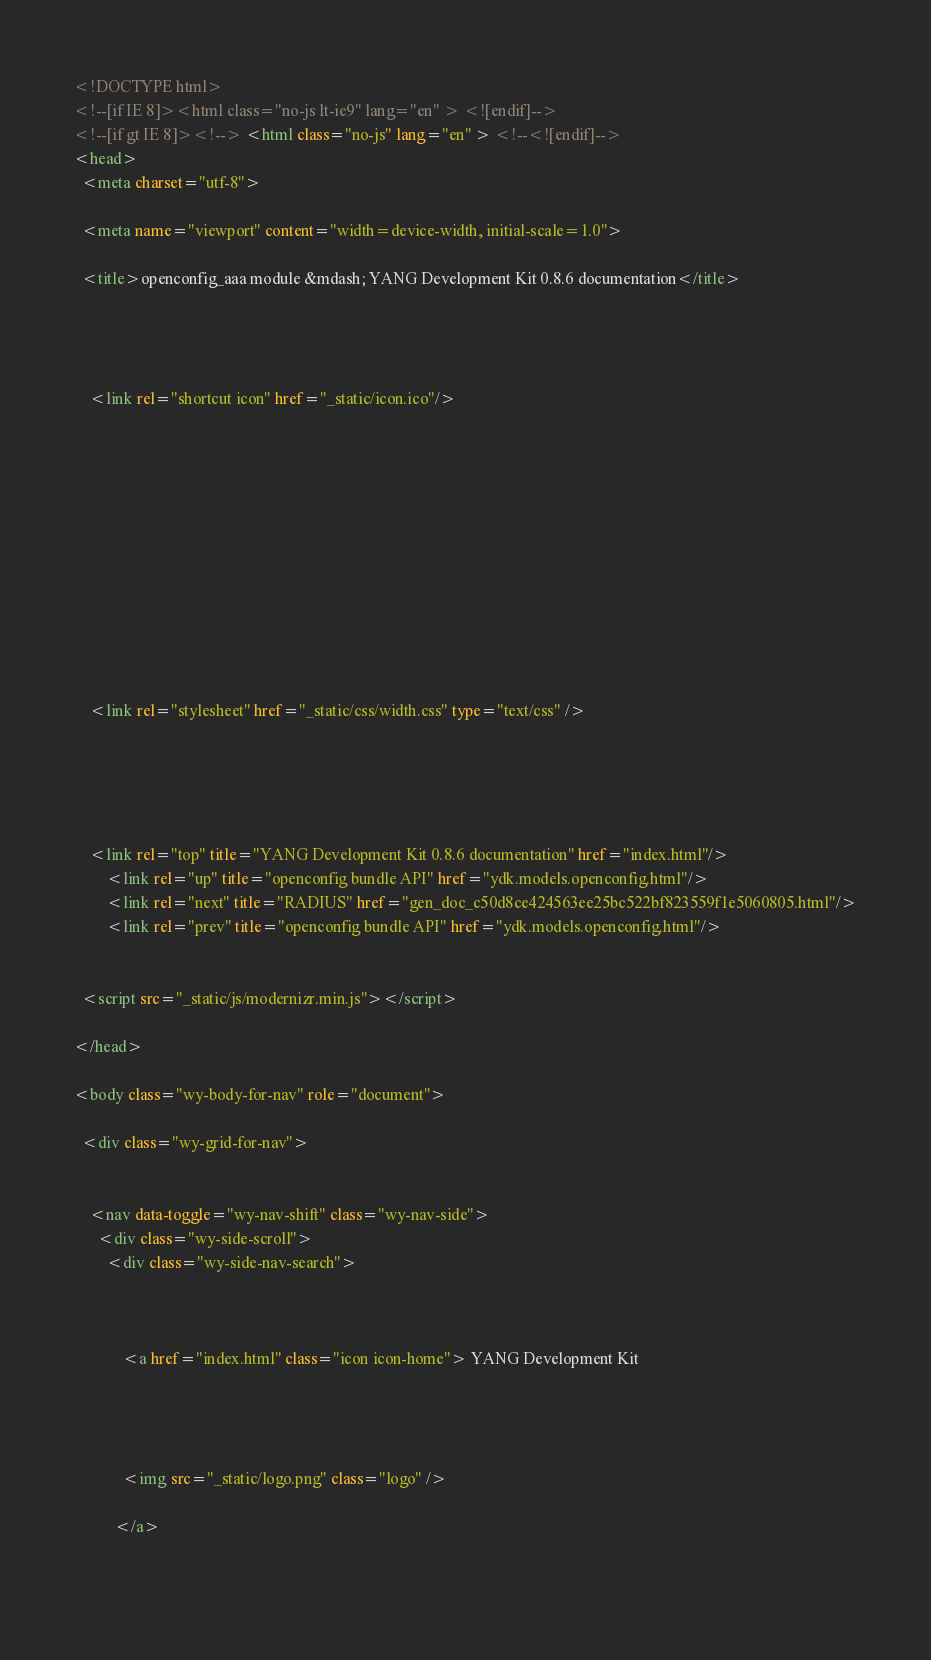Convert code to text. <code><loc_0><loc_0><loc_500><loc_500><_HTML_>

<!DOCTYPE html>
<!--[if IE 8]><html class="no-js lt-ie9" lang="en" > <![endif]-->
<!--[if gt IE 8]><!--> <html class="no-js" lang="en" > <!--<![endif]-->
<head>
  <meta charset="utf-8">
  
  <meta name="viewport" content="width=device-width, initial-scale=1.0">
  
  <title>openconfig_aaa module &mdash; YANG Development Kit 0.8.6 documentation</title>
  

  
  
    <link rel="shortcut icon" href="_static/icon.ico"/>
  

  

  
  
    

  

  
  
    <link rel="stylesheet" href="_static/css/width.css" type="text/css" />
  

  

  
    <link rel="top" title="YANG Development Kit 0.8.6 documentation" href="index.html"/>
        <link rel="up" title="openconfig bundle API" href="ydk.models.openconfig.html"/>
        <link rel="next" title="RADIUS" href="gen_doc_c50d8ce424563ee25bc522bf823559f1e5060805.html"/>
        <link rel="prev" title="openconfig bundle API" href="ydk.models.openconfig.html"/> 

  
  <script src="_static/js/modernizr.min.js"></script>

</head>

<body class="wy-body-for-nav" role="document">

  <div class="wy-grid-for-nav">

    
    <nav data-toggle="wy-nav-shift" class="wy-nav-side">
      <div class="wy-side-scroll">
        <div class="wy-side-nav-search">
          

          
            <a href="index.html" class="icon icon-home"> YANG Development Kit
          

          
            
            <img src="_static/logo.png" class="logo" />
          
          </a>

          </code> 